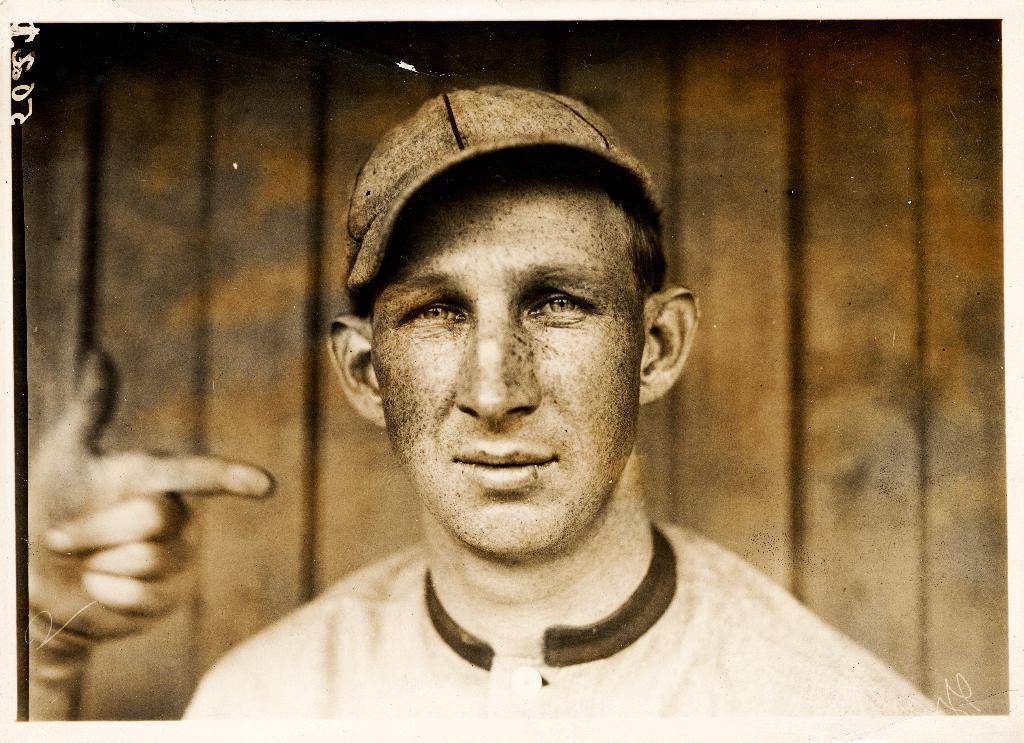Please provide a concise description of this image. This is an edited image. In front of the picture, we see a man. He is wearing a cap and he is looking at the camera. On the left side, we see the hand of a person which is pointing the finger towards something. In the background, we see a wooden wall. This picture might be a photo frame. 